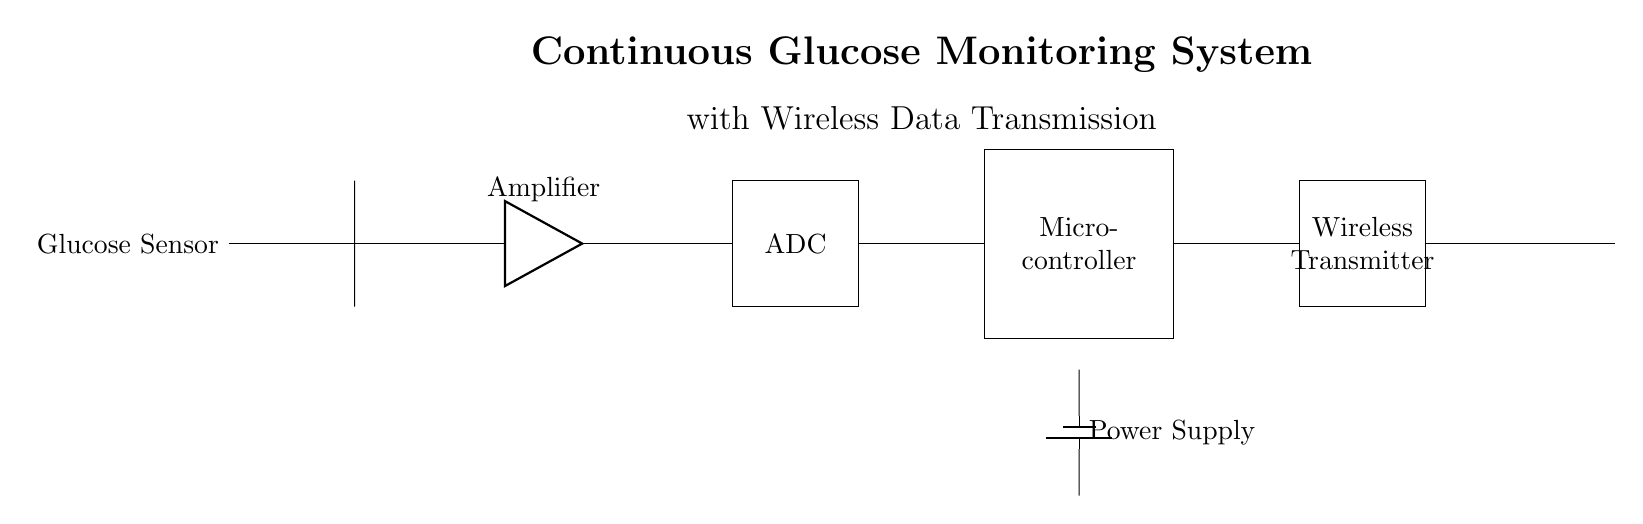What is the purpose of the glucose sensor? The glucose sensor is responsible for detecting and measuring the glucose levels in the user's body. It is the initial component that gathers the required biochemical data for the monitoring system.
Answer: Detecting glucose levels What component amplifies the signal from the glucose sensor? The amplifier is connected directly after the glucose sensor, where it boosts the signal strength. Amplifiers are essential in signal processing to ensure the signal can be effectively processed later.
Answer: Amplifier What component converts analog signals to digital? The analog-to-digital converter (ADC) is the component that takes the analog signals generated by the glucose sensor and converts them into digital form so that the microcontroller can read the data.
Answer: ADC Which component has wireless transmission capabilities? The wireless transmitter is the designated component in the circuit responsible for transmitting data wirelessly, allowing for real-time monitoring of glucose levels without needing a physical connection.
Answer: Wireless Transmitter How is power supplied to the circuit? The circuit is powered by a battery, depicted at the bottom connecting to the microcontroller, indicating that the entire system relies on this power supply for operation and processing.
Answer: Battery What is the function of the microcontroller in the system? The microcontroller processes the digital signals from the ADC, executes any necessary computations, and manages data communication to the wireless transmitter. It acts as the brain of the system, integrating the functionalities of all other components.
Answer: Processing data 